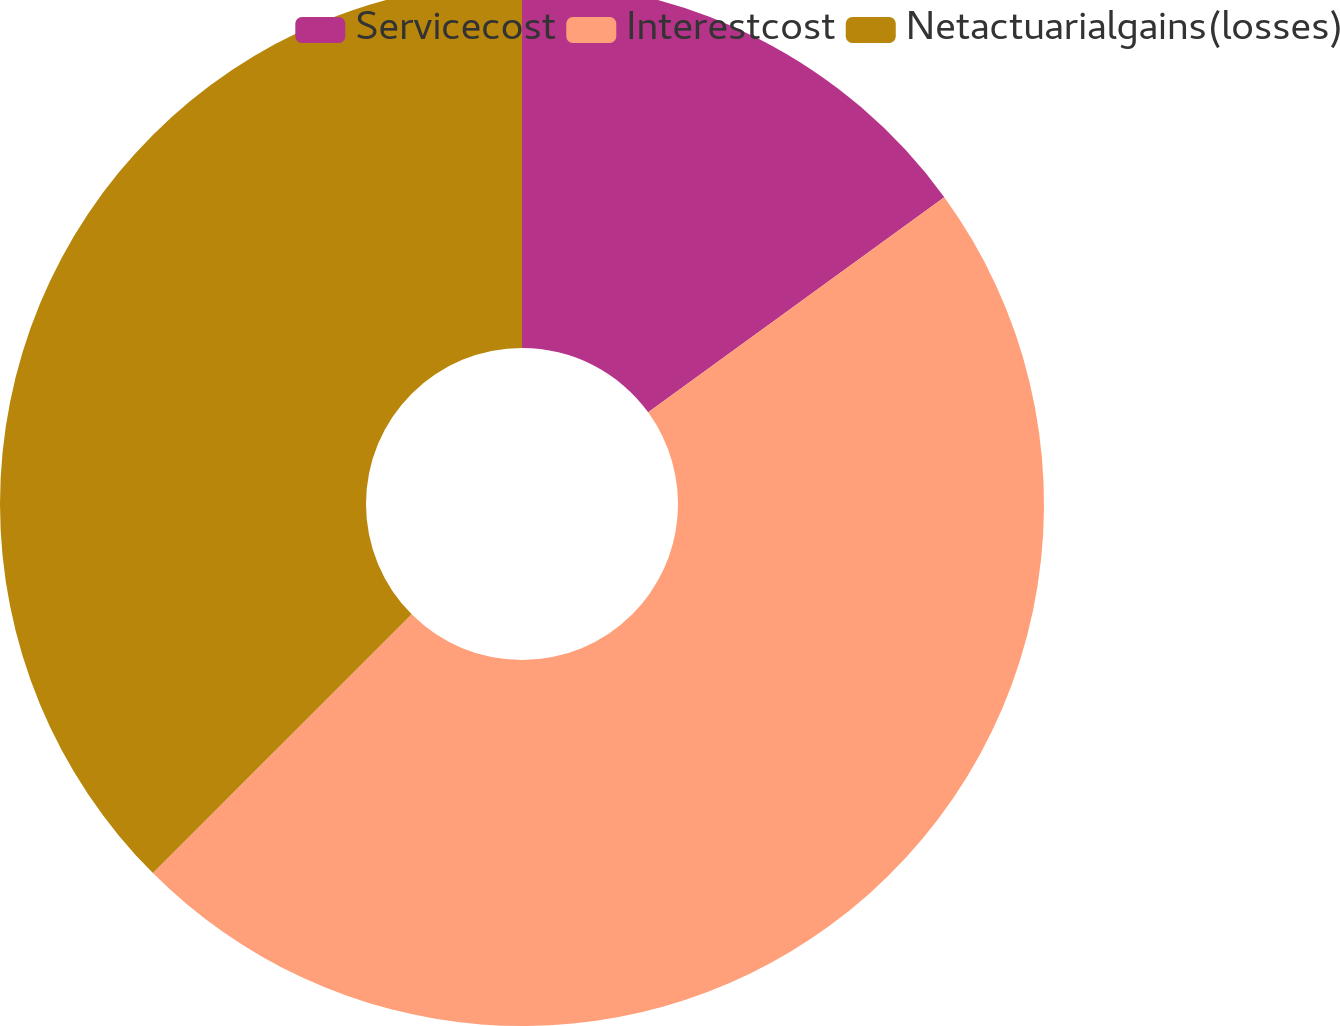Convert chart to OTSL. <chart><loc_0><loc_0><loc_500><loc_500><pie_chart><fcel>Servicecost<fcel>Interestcost<fcel>Netactuarialgains(losses)<nl><fcel>15.0%<fcel>47.5%<fcel>37.5%<nl></chart> 